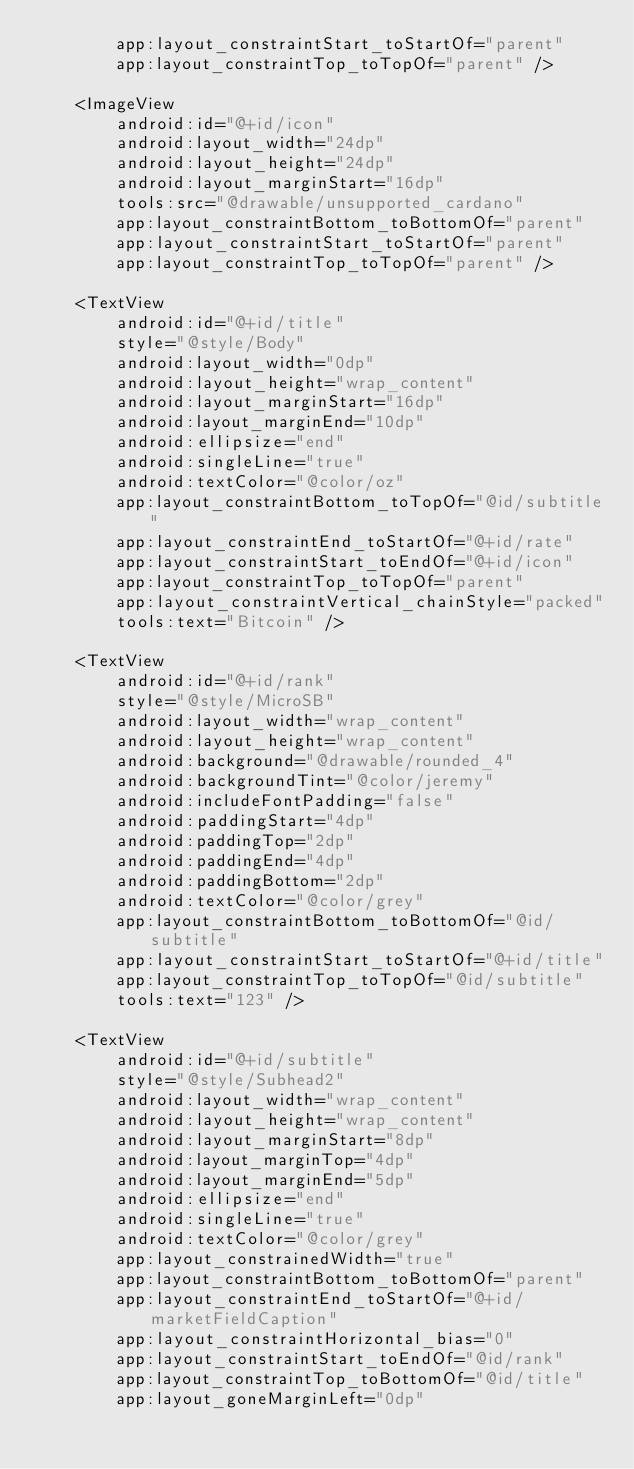<code> <loc_0><loc_0><loc_500><loc_500><_XML_>        app:layout_constraintStart_toStartOf="parent"
        app:layout_constraintTop_toTopOf="parent" />

    <ImageView
        android:id="@+id/icon"
        android:layout_width="24dp"
        android:layout_height="24dp"
        android:layout_marginStart="16dp"
        tools:src="@drawable/unsupported_cardano"
        app:layout_constraintBottom_toBottomOf="parent"
        app:layout_constraintStart_toStartOf="parent"
        app:layout_constraintTop_toTopOf="parent" />

    <TextView
        android:id="@+id/title"
        style="@style/Body"
        android:layout_width="0dp"
        android:layout_height="wrap_content"
        android:layout_marginStart="16dp"
        android:layout_marginEnd="10dp"
        android:ellipsize="end"
        android:singleLine="true"
        android:textColor="@color/oz"
        app:layout_constraintBottom_toTopOf="@id/subtitle"
        app:layout_constraintEnd_toStartOf="@+id/rate"
        app:layout_constraintStart_toEndOf="@+id/icon"
        app:layout_constraintTop_toTopOf="parent"
        app:layout_constraintVertical_chainStyle="packed"
        tools:text="Bitcoin" />

    <TextView
        android:id="@+id/rank"
        style="@style/MicroSB"
        android:layout_width="wrap_content"
        android:layout_height="wrap_content"
        android:background="@drawable/rounded_4"
        android:backgroundTint="@color/jeremy"
        android:includeFontPadding="false"
        android:paddingStart="4dp"
        android:paddingTop="2dp"
        android:paddingEnd="4dp"
        android:paddingBottom="2dp"
        android:textColor="@color/grey"
        app:layout_constraintBottom_toBottomOf="@id/subtitle"
        app:layout_constraintStart_toStartOf="@+id/title"
        app:layout_constraintTop_toTopOf="@id/subtitle"
        tools:text="123" />

    <TextView
        android:id="@+id/subtitle"
        style="@style/Subhead2"
        android:layout_width="wrap_content"
        android:layout_height="wrap_content"
        android:layout_marginStart="8dp"
        android:layout_marginTop="4dp"
        android:layout_marginEnd="5dp"
        android:ellipsize="end"
        android:singleLine="true"
        android:textColor="@color/grey"
        app:layout_constrainedWidth="true"
        app:layout_constraintBottom_toBottomOf="parent"
        app:layout_constraintEnd_toStartOf="@+id/marketFieldCaption"
        app:layout_constraintHorizontal_bias="0"
        app:layout_constraintStart_toEndOf="@id/rank"
        app:layout_constraintTop_toBottomOf="@id/title"
        app:layout_goneMarginLeft="0dp"</code> 